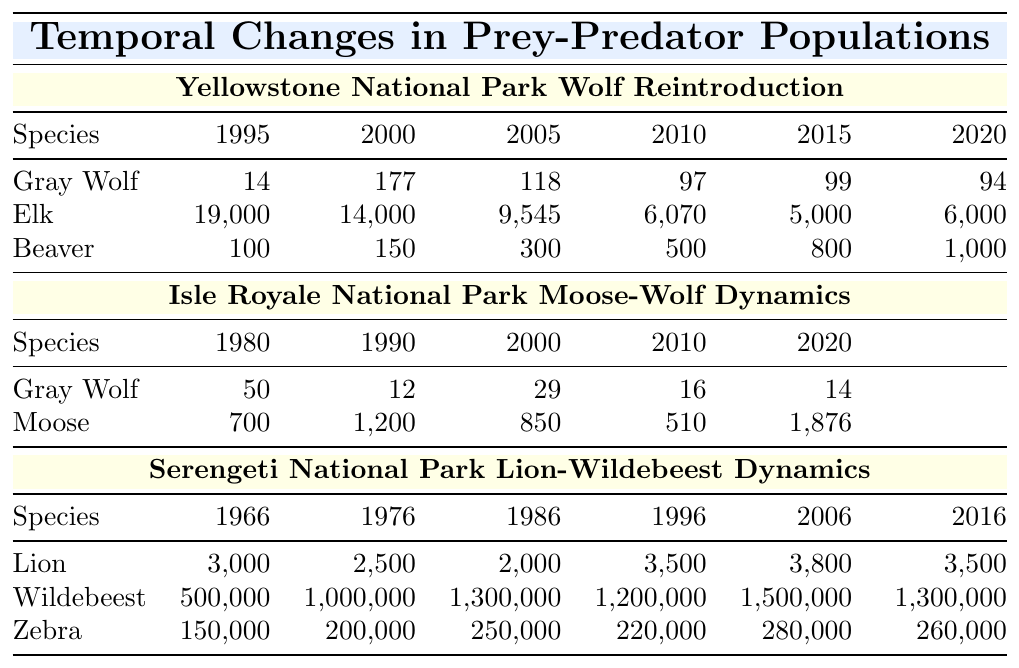What was the population of gray wolves in Yellowstone National Park in 2000? From the table, we can see that the gray wolf population in Yellowstone National Park in the year 2000 is listed as 177.
Answer: 177 What was the elk population in Yellowstone National Park in 2010? The table shows that the elk population in Yellowstone National Park in the year 2010 is recorded as 6070.
Answer: 6070 In which year did the beaver population in Yellowstone National Park exceed 800? The beaver population exceeded 800 in the year 2015, as shown in the table.
Answer: 2015 What was the average gray wolf population in the Isle Royale National Park between 1980 and 2020? The populations from 1980 (50), 1990 (12), 2000 (29), 2010 (16), and 2020 (14) sum up to 121. Dividing by the number of years (5) gives an average of 24.2.
Answer: 24.2 Did the moose population in Isle Royale National Park increase from 2010 to 2020? In 2010, the moose population was 510, and in 2020 it rose to 1876. Thus, it did increase.
Answer: Yes What was the percentage decrease in the elk population from 1995 to 2005 in Yellowstone National Park? The elk population decreased from 19000 in 1995 to 9545 in 2005. The decrease is 19000 - 9545 = 9455. To find the percentage decrease, divide the decrease by the original population: (9455/19000) * 100 = 49.74%.
Answer: 49.74% Which park showed a significant increase in the moose population from 2010 to 2020? The Isle Royale National Park's moose population increased from 510 in 2010 to 1876 in 2020, showing a significant increase.
Answer: Isle Royale National Park How many more beavers were there in Yellowstone National Park in 2020 compared to the gray wolf population? In 2020, the beaver population was 1000 and the gray wolf population was 94. The difference is 1000 - 94 = 906.
Answer: 906 What trend is visible in the lion population in the Serengeti National Park between 1966 and 2016? The lion population initially decreased from 3000 in 1966 to 2000 in 1986, then increased to 3500 by 1996, slightly decreased to 3500 in 2016, showing fluctuations over the years.
Answer: Fluctuating trend What is the total population of wildebeests in the Serengeti National Park for the years recorded? Adding the populations from each year: 500,000 (1966) + 1,000,000 (1976) + 1,300,000 (1986) + 1,200,000 (1996) + 1,500,000 (2006) + 1,300,000 (2016) = 6,800,000.
Answer: 6,800,000 In the Yellowstone National Park, what was the overall population change for the elk from 1995 to 2020? The elk population decreased from 19000 in 1995 to 6000 in 2020, showing a decline of 13000 over 25 years, prominent in its effect on ecosystem dynamics.
Answer: Decrease of 13,000 